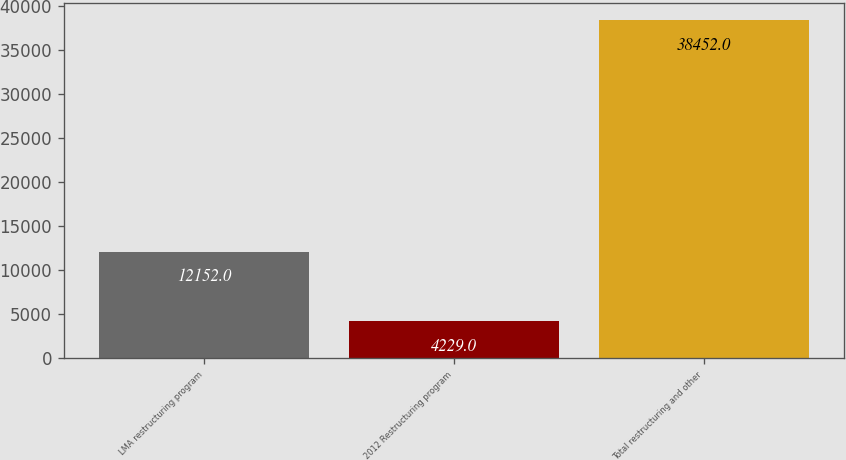<chart> <loc_0><loc_0><loc_500><loc_500><bar_chart><fcel>LMA restructuring program<fcel>2012 Restructuring program<fcel>Total restructuring and other<nl><fcel>12152<fcel>4229<fcel>38452<nl></chart> 